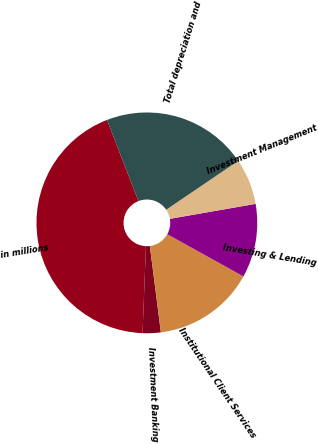Convert chart. <chart><loc_0><loc_0><loc_500><loc_500><pie_chart><fcel>in millions<fcel>Investment Banking<fcel>Institutional Client Services<fcel>Investing & Lending<fcel>Investment Management<fcel>Total depreciation and<nl><fcel>43.49%<fcel>2.65%<fcel>14.91%<fcel>10.82%<fcel>6.74%<fcel>21.39%<nl></chart> 